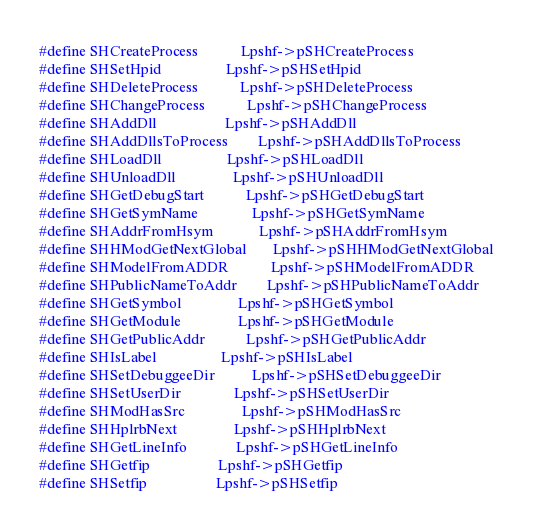<code> <loc_0><loc_0><loc_500><loc_500><_C_>#define SHCreateProcess           Lpshf->pSHCreateProcess
#define SHSetHpid                 Lpshf->pSHSetHpid
#define SHDeleteProcess           Lpshf->pSHDeleteProcess
#define SHChangeProcess           Lpshf->pSHChangeProcess
#define SHAddDll                  Lpshf->pSHAddDll
#define SHAddDllsToProcess        Lpshf->pSHAddDllsToProcess
#define SHLoadDll                 Lpshf->pSHLoadDll
#define SHUnloadDll               Lpshf->pSHUnloadDll
#define SHGetDebugStart           Lpshf->pSHGetDebugStart
#define SHGetSymName              Lpshf->pSHGetSymName
#define SHAddrFromHsym            Lpshf->pSHAddrFromHsym
#define SHHModGetNextGlobal       Lpshf->pSHHModGetNextGlobal
#define SHModelFromADDR           Lpshf->pSHModelFromADDR
#define SHPublicNameToAddr        Lpshf->pSHPublicNameToAddr
#define SHGetSymbol               Lpshf->pSHGetSymbol
#define SHGetModule               Lpshf->pSHGetModule
#define SHGetPublicAddr           Lpshf->pSHGetPublicAddr
#define SHIsLabel                 Lpshf->pSHIsLabel
#define SHSetDebuggeeDir          Lpshf->pSHSetDebuggeeDir
#define SHSetUserDir              Lpshf->pSHSetUserDir
#define SHModHasSrc               Lpshf->pSHModHasSrc
#define SHHplrbNext               Lpshf->pSHHplrbNext
#define SHGetLineInfo             Lpshf->pSHGetLineInfo
#define SHGetfip                  Lpshf->pSHGetfip
#define SHSetfip                  Lpshf->pSHSetfip</code> 